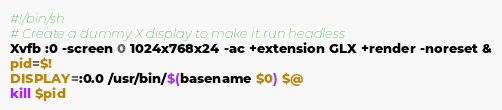Convert code to text. <code><loc_0><loc_0><loc_500><loc_500><_Bash_>#!/bin/sh
# Create a dummy X display to make it run headless
Xvfb :0 -screen 0 1024x768x24 -ac +extension GLX +render -noreset &
pid=$!
DISPLAY=:0.0 /usr/bin/$(basename $0) $@
kill $pid
</code> 